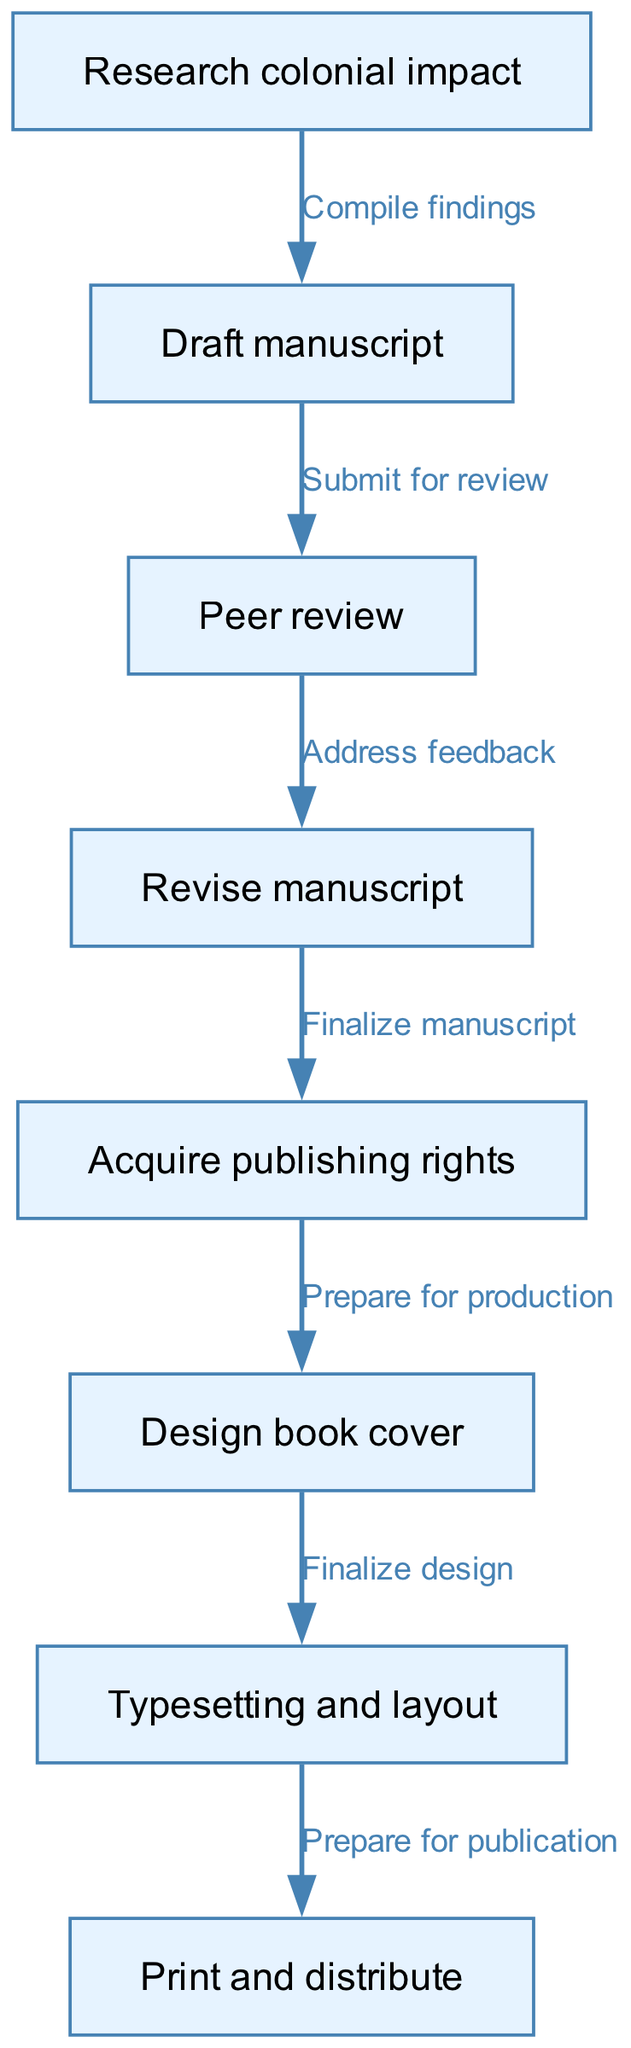What is the first step in the publishing process? The diagram indicates that the first node in the flow is "Research colonial impact," which is where the process begins.
Answer: Research colonial impact How many nodes are present in the diagram? The diagram lists a total of eight distinct nodes that represent the steps of the publishing process.
Answer: Eight What follows after "Draft manuscript"? According to the diagram, the next step after "Draft manuscript" is "Peer review," which indicates that the manuscript is submitted for review.
Answer: Peer review What action needs to be taken after "Revise manuscript"? The flowchart shows that after "Revise manuscript," the next step is "Acquire publishing rights," indicating the conclusion of the revision stage.
Answer: Acquire publishing rights What is the last step in the flowchart? The final node in the flowchart is "Print and distribute," marking the end of the publishing process.
Answer: Print and distribute How do you proceed from "Peer review" to "Revise manuscript"? The transition from "Peer review" to "Revise manuscript" indicates that feedback is addressed, showing a direct connection between these two nodes.
Answer: Address feedback What are the two steps that occur after "Acquire publishing rights"? The diagram shows that the two subsequent steps after "Acquire publishing rights" are "Design book cover" and "Prepare for production," which are necessary for proceeding further in publishing.
Answer: Design book cover, Prepare for production What is the relationship between "Design book cover" and "Typesetting and layout"? The relationship is sequential, indicated in the flowchart, where "Typesetting and layout" follows directly after "Design book cover," revealing the structured process in publishing.
Answer: Finalize design What must be completed at the "Revise manuscript" stage? At the "Revise manuscript" stage, the action required is "Address feedback," which signifies that necessary revisions should be applied according to the peer review comments.
Answer: Address feedback 